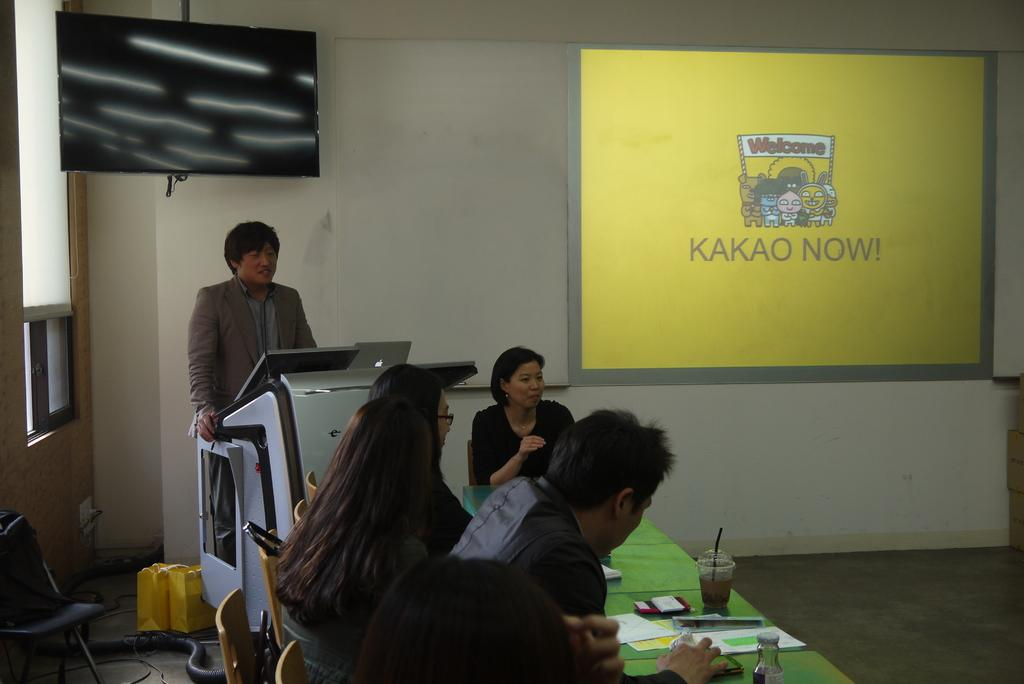<image>
Render a clear and concise summary of the photo. A group of people sit at a green covered table looking at a presentation for KAKAO NOW! 